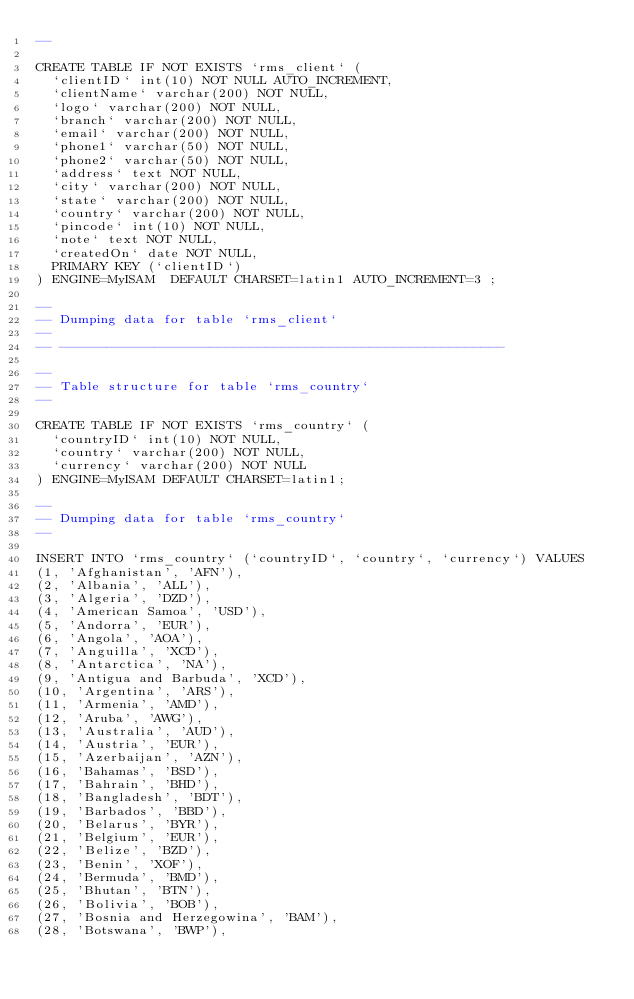Convert code to text. <code><loc_0><loc_0><loc_500><loc_500><_SQL_>--

CREATE TABLE IF NOT EXISTS `rms_client` (
  `clientID` int(10) NOT NULL AUTO_INCREMENT,
  `clientName` varchar(200) NOT NULL,
  `logo` varchar(200) NOT NULL,
  `branch` varchar(200) NOT NULL,
  `email` varchar(200) NOT NULL,
  `phone1` varchar(50) NOT NULL,
  `phone2` varchar(50) NOT NULL,
  `address` text NOT NULL,
  `city` varchar(200) NOT NULL,
  `state` varchar(200) NOT NULL,
  `country` varchar(200) NOT NULL,
  `pincode` int(10) NOT NULL,
  `note` text NOT NULL,
  `createdOn` date NOT NULL,
  PRIMARY KEY (`clientID`)
) ENGINE=MyISAM  DEFAULT CHARSET=latin1 AUTO_INCREMENT=3 ;

--
-- Dumping data for table `rms_client`
--
-- --------------------------------------------------------

--
-- Table structure for table `rms_country`
--

CREATE TABLE IF NOT EXISTS `rms_country` (
  `countryID` int(10) NOT NULL,
  `country` varchar(200) NOT NULL,
  `currency` varchar(200) NOT NULL
) ENGINE=MyISAM DEFAULT CHARSET=latin1;

--
-- Dumping data for table `rms_country`
--

INSERT INTO `rms_country` (`countryID`, `country`, `currency`) VALUES
(1, 'Afghanistan', 'AFN'),
(2, 'Albania', 'ALL'),
(3, 'Algeria', 'DZD'),
(4, 'American Samoa', 'USD'),
(5, 'Andorra', 'EUR'),
(6, 'Angola', 'AOA'),
(7, 'Anguilla', 'XCD'),
(8, 'Antarctica', 'NA'),
(9, 'Antigua and Barbuda', 'XCD'),
(10, 'Argentina', 'ARS'),
(11, 'Armenia', 'AMD'),
(12, 'Aruba', 'AWG'),
(13, 'Australia', 'AUD'),
(14, 'Austria', 'EUR'),
(15, 'Azerbaijan', 'AZN'),
(16, 'Bahamas', 'BSD'),
(17, 'Bahrain', 'BHD'),
(18, 'Bangladesh', 'BDT'),
(19, 'Barbados', 'BBD'),
(20, 'Belarus', 'BYR'),
(21, 'Belgium', 'EUR'),
(22, 'Belize', 'BZD'),
(23, 'Benin', 'XOF'),
(24, 'Bermuda', 'BMD'),
(25, 'Bhutan', 'BTN'),
(26, 'Bolivia', 'BOB'),
(27, 'Bosnia and Herzegowina', 'BAM'),
(28, 'Botswana', 'BWP'),</code> 